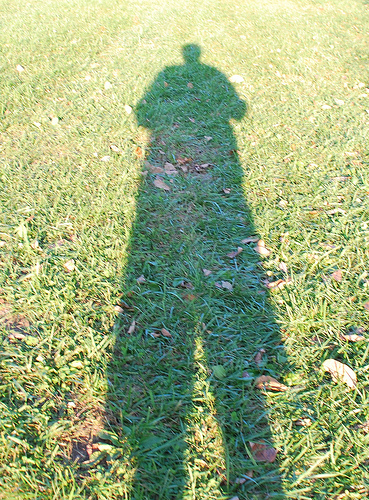<image>
Is the shadow to the left of the grass? No. The shadow is not to the left of the grass. From this viewpoint, they have a different horizontal relationship. 